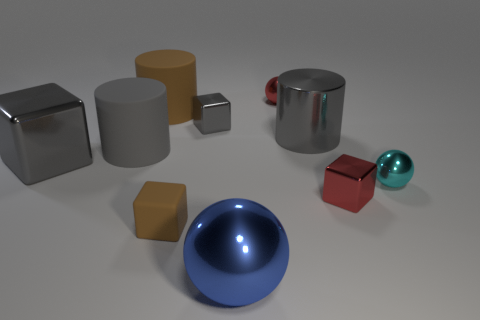Subtract all cyan balls. How many gray cylinders are left? 2 Subtract all small red blocks. How many blocks are left? 3 Subtract all brown cubes. How many cubes are left? 3 Subtract 1 cylinders. How many cylinders are left? 2 Subtract all purple blocks. Subtract all brown spheres. How many blocks are left? 4 Subtract all cylinders. How many objects are left? 7 Subtract 0 green cylinders. How many objects are left? 10 Subtract all large blue metal things. Subtract all blue metal spheres. How many objects are left? 8 Add 7 brown matte objects. How many brown matte objects are left? 9 Add 5 gray metal cubes. How many gray metal cubes exist? 7 